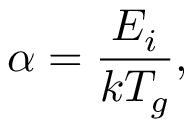Convert formula to latex. <formula><loc_0><loc_0><loc_500><loc_500>\alpha = \frac { E _ { i } } { k T _ { g } } ,</formula> 